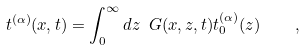Convert formula to latex. <formula><loc_0><loc_0><loc_500><loc_500>t ^ { ( \alpha ) } ( x , t ) = \int _ { 0 } ^ { \infty } d z \ G ( x , z , t ) t ^ { ( \alpha ) } _ { 0 } ( z ) \quad ,</formula> 